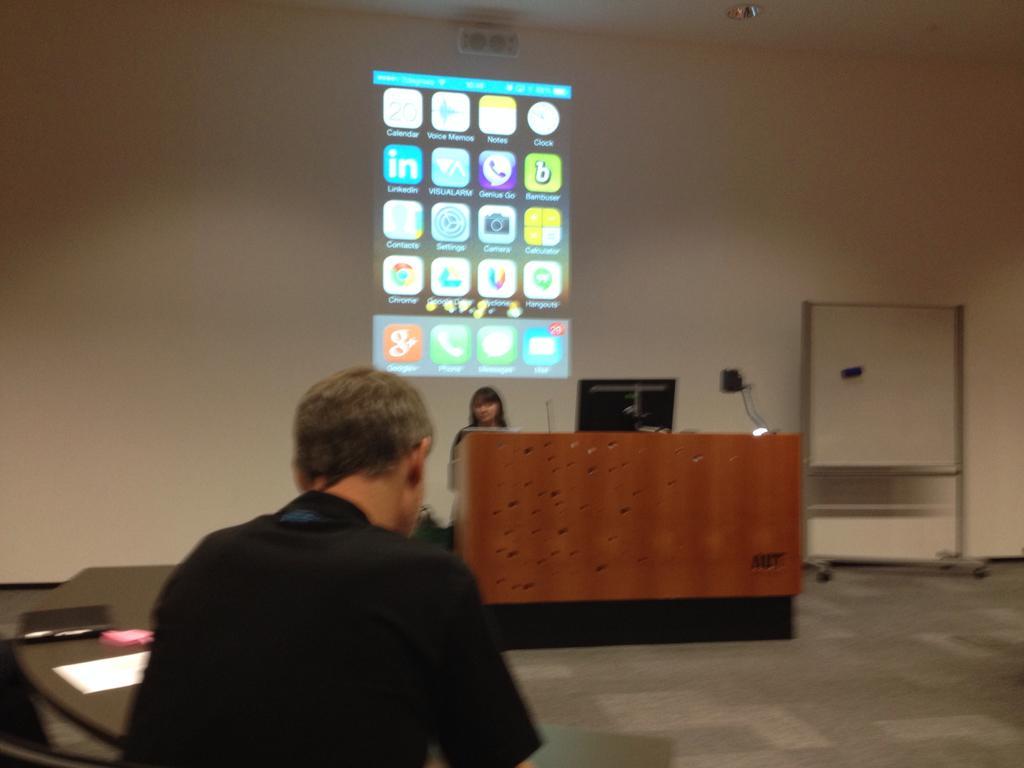In one or two sentences, can you explain what this image depicts? In this image there is a man sitting near the table. In the background there is a girl standing near the table. On the table there is a laptop and a lamp beside it. On the wall there is a screen. On the right side there is an iron stand. On the left side there is a table on which there are papers and files. At the top there is light. 